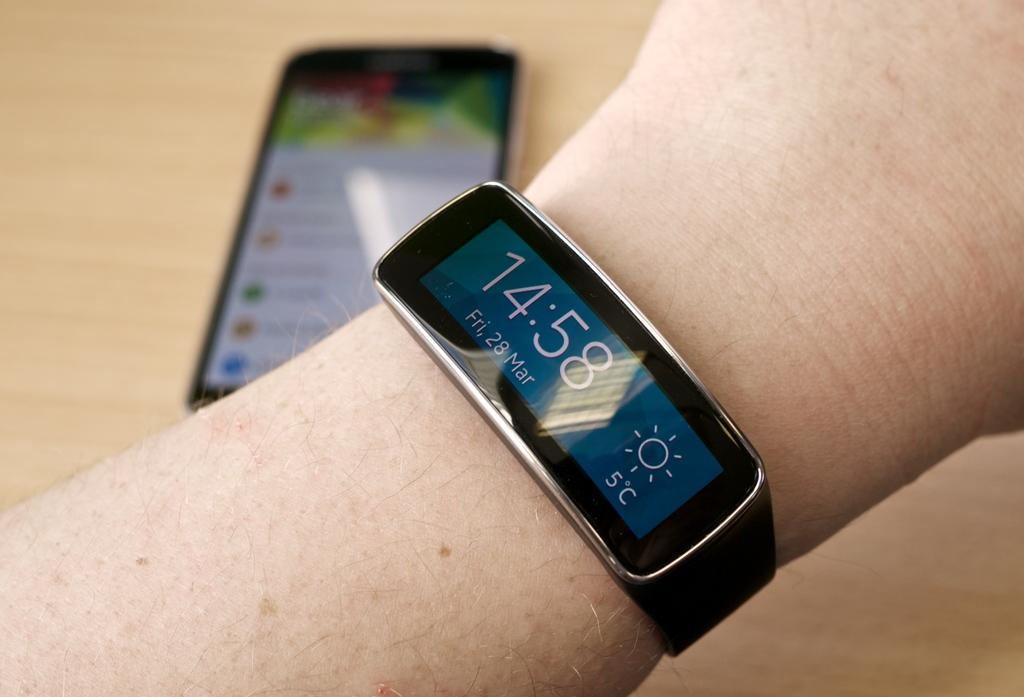<image>
Describe the image concisely. A rectangular wrist watch that reads 14:58 for Friday, the 28 of March displayed along with 5 celsius and sunny symbol 